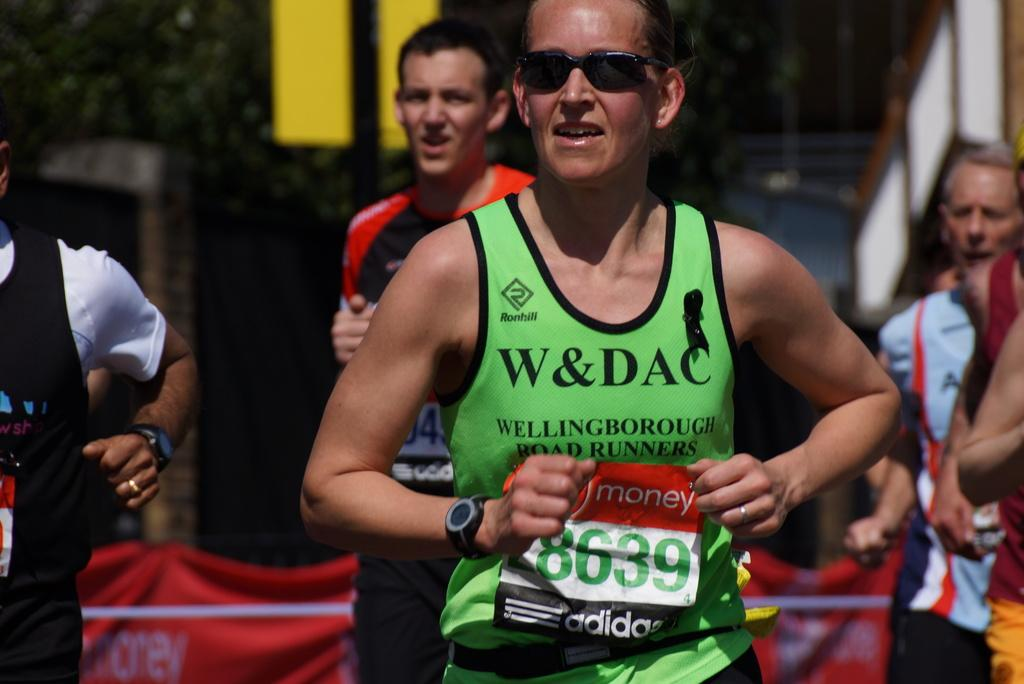<image>
Describe the image concisely. A man, wearing a green W&DAC jersey, runs. 